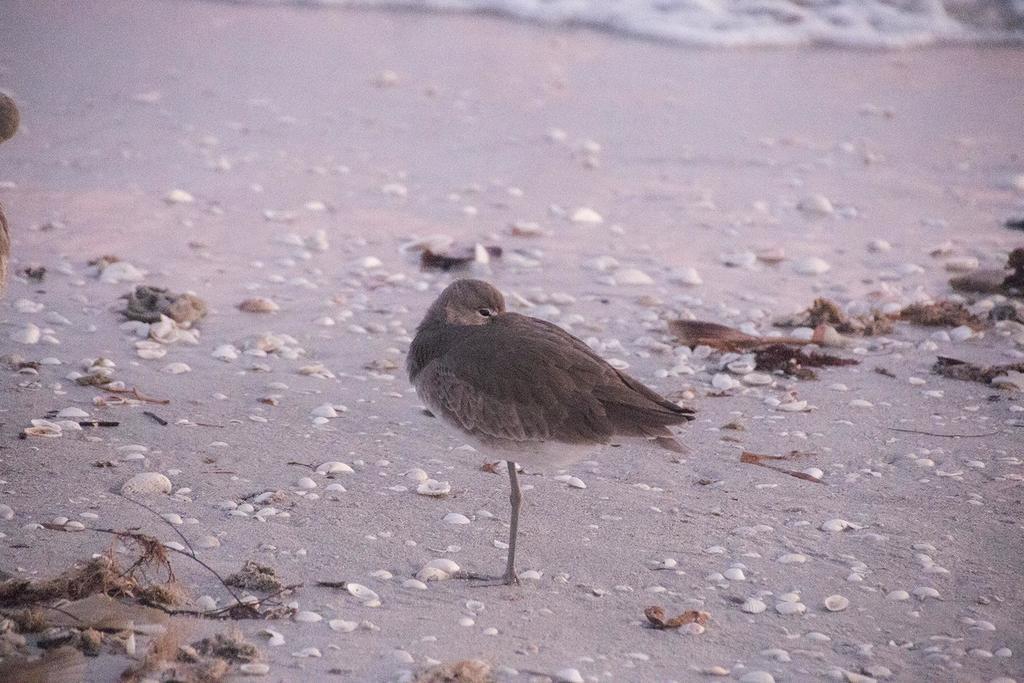Please provide a concise description of this image. In this image I can see the bird standing on the sand. To the side of the bird I can see many stones and some brown color objects. In the background I can see the water. 